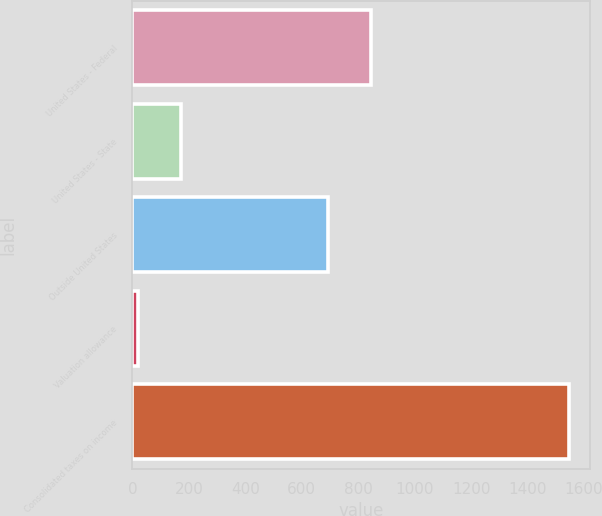Convert chart to OTSL. <chart><loc_0><loc_0><loc_500><loc_500><bar_chart><fcel>United States - Federal<fcel>United States - State<fcel>Outside United States<fcel>Valuation allowance<fcel>Consolidated taxes on income<nl><fcel>845.4<fcel>173.4<fcel>693<fcel>21<fcel>1545<nl></chart> 